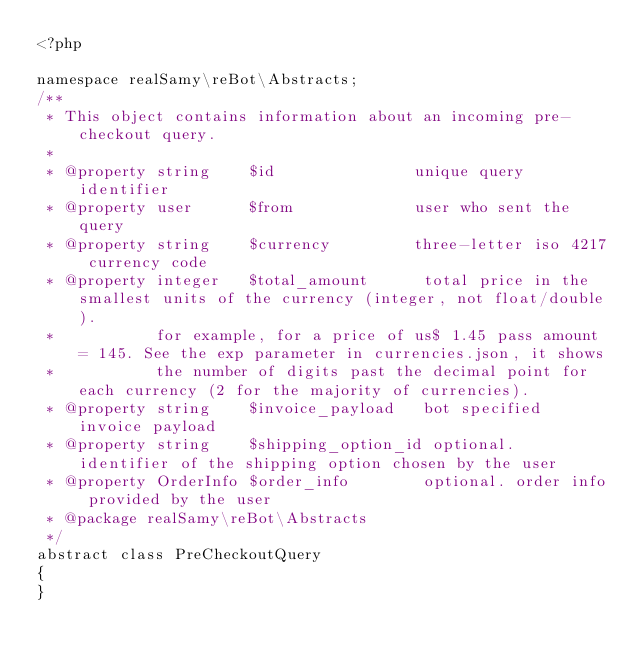<code> <loc_0><loc_0><loc_500><loc_500><_PHP_><?php

namespace realSamy\reBot\Abstracts;
/**
 * This object contains information about an incoming pre-checkout query.
 *
 * @property string    $id               unique query identifier
 * @property user      $from             user who sent the query
 * @property string    $currency         three-letter iso 4217 currency code
 * @property integer   $total_amount      total price in the smallest units of the currency (integer, not float/double).
 *           for example, for a price of us$ 1.45 pass amount = 145. See the exp parameter in currencies.json, it shows
 *           the number of digits past the decimal point for each currency (2 for the majority of currencies).
 * @property string    $invoice_payload   bot specified invoice payload
 * @property string    $shipping_option_id optional. identifier of the shipping option chosen by the user
 * @property OrderInfo $order_info        optional. order info provided by the user
 * @package realSamy\reBot\Abstracts
 */
abstract class PreCheckoutQuery
{
}</code> 